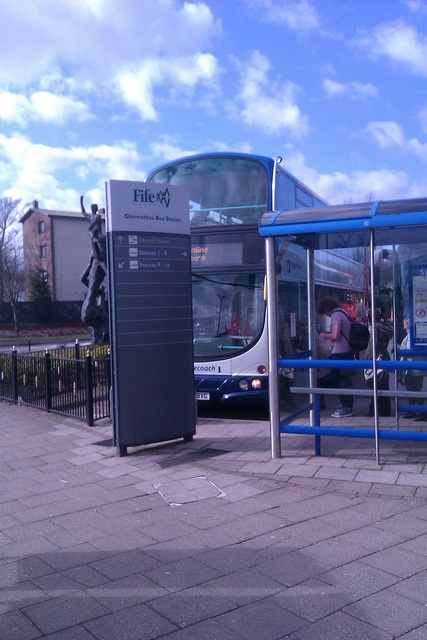Describe the objects in this image and their specific colors. I can see bus in lavender, gray, navy, and darkblue tones, people in lavender, black, navy, and purple tones, people in lavender, black, navy, purple, and gray tones, people in lavender, purple, navy, and gray tones, and backpack in lavender, black, gray, and navy tones in this image. 